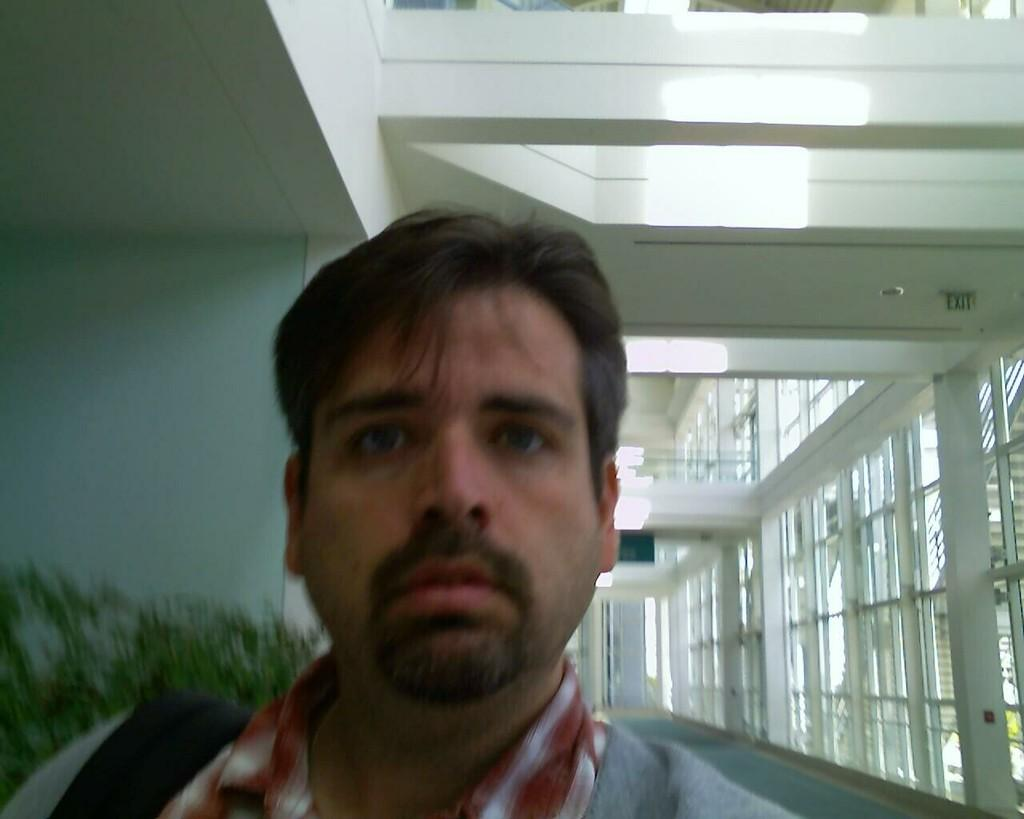Who is present in the image? There is a man in the image. What is the man wearing? The man is wearing a shirt. What item does the man have with him? The man has a bag. What can be seen in the background of the image? There are plants, at least one building, windows, glasses, and a wall in the background of the image. What type of dog is sitting next to the man in the image? There is no dog present in the image; only the man and the background elements are visible. 